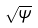<formula> <loc_0><loc_0><loc_500><loc_500>\sqrt { \psi }</formula> 